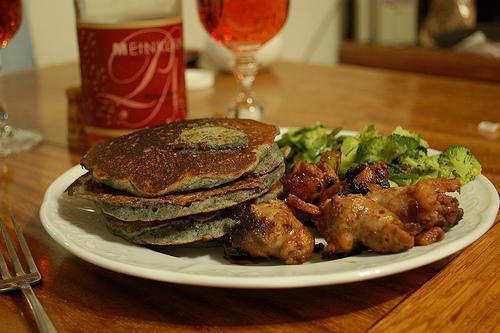How many plates are there?
Give a very brief answer. 1. 